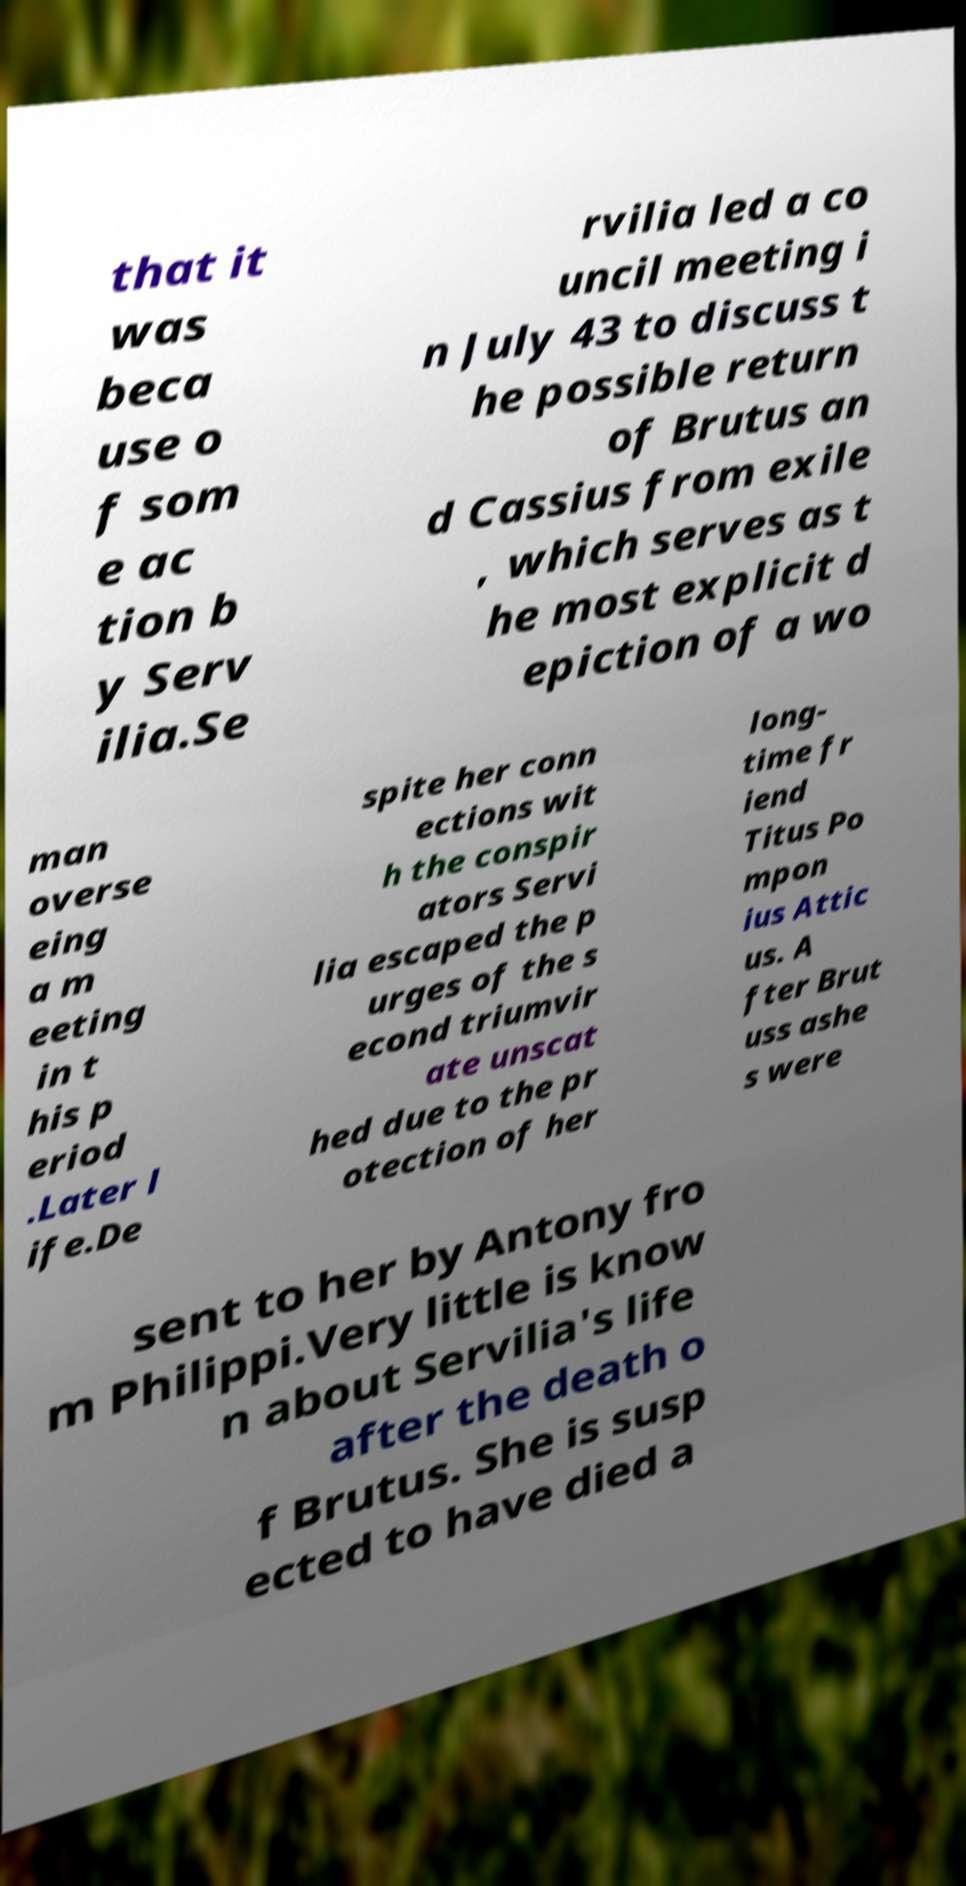Can you accurately transcribe the text from the provided image for me? that it was beca use o f som e ac tion b y Serv ilia.Se rvilia led a co uncil meeting i n July 43 to discuss t he possible return of Brutus an d Cassius from exile , which serves as t he most explicit d epiction of a wo man overse eing a m eeting in t his p eriod .Later l ife.De spite her conn ections wit h the conspir ators Servi lia escaped the p urges of the s econd triumvir ate unscat hed due to the pr otection of her long- time fr iend Titus Po mpon ius Attic us. A fter Brut uss ashe s were sent to her by Antony fro m Philippi.Very little is know n about Servilia's life after the death o f Brutus. She is susp ected to have died a 